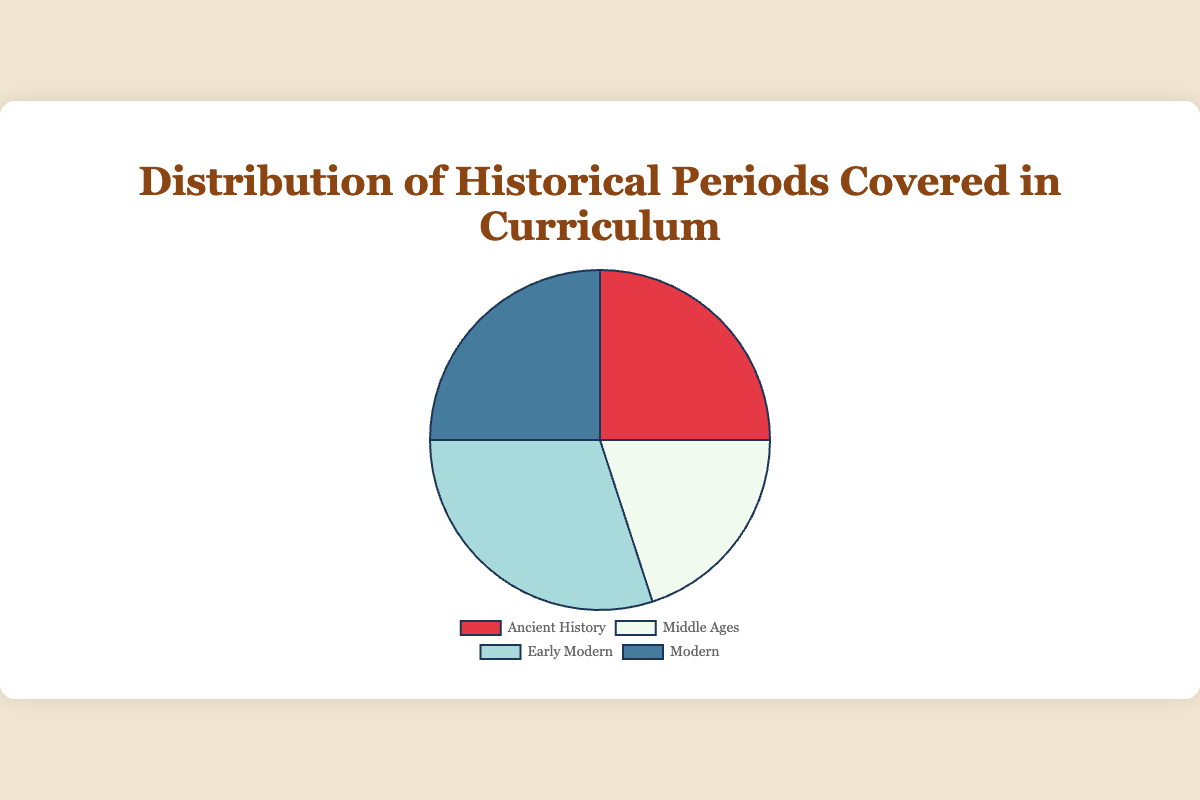What percentage of the curriculum is dedicated to Ancient History and Modern combined? Add the percentages of Ancient History (25%) and Modern (25%) together. 25% + 25% = 50%
Answer: 50% Which historical period covers the smallest percentage of the curriculum? Compare the percentages of all periods: Ancient History (25%), Middle Ages (20%), Early Modern (30%), Modern (25%). Middle Ages has the smallest percentage (20%).
Answer: Middle Ages By what percentage does Early Modern history coverage exceed that of the Middle Ages? Subtract the percentage of Middle Ages (20%) from the percentage of Early Modern (30%). 30% - 20% = 10%
Answer: 10% What is the difference between the highest and lowest percentages covered by the historical periods? The highest percentage is Early Modern (30%) and the lowest is Middle Ages (20%). Subtract the two: 30% - 20% = 10%
Answer: 10% Which historical periods cover the same percentage of the curriculum? Compare the percentages of all periods: Ancient History (25%), Middle Ages (20%), Early Modern (30%), and Modern (25%). Ancient History and Modern both cover 25%.
Answer: Ancient History and Modern If the Early Modern period coverage was reduced by 5 percentage points and added to the Middle Ages, what would be the new percentage coverage for these two periods? Reduce Early Modern by 5%: 30% - 5% = 25%. Increase Middle Ages by 5%: 20% + 5% = 25%.
Answer: Early Modern: 25%, Middle Ages: 25% What is the total percentage covered by the periods that are not Early Modern? Sum the percentages of Ancient History (25%), Middle Ages (20%), and Modern (25%). 25% + 20% + 25% = 70%
Answer: 70% Which period has the blue color in the pie chart? Identify the color assigned to Early Modern, which in this chart's data corresponds to blue.
Answer: Early Modern 